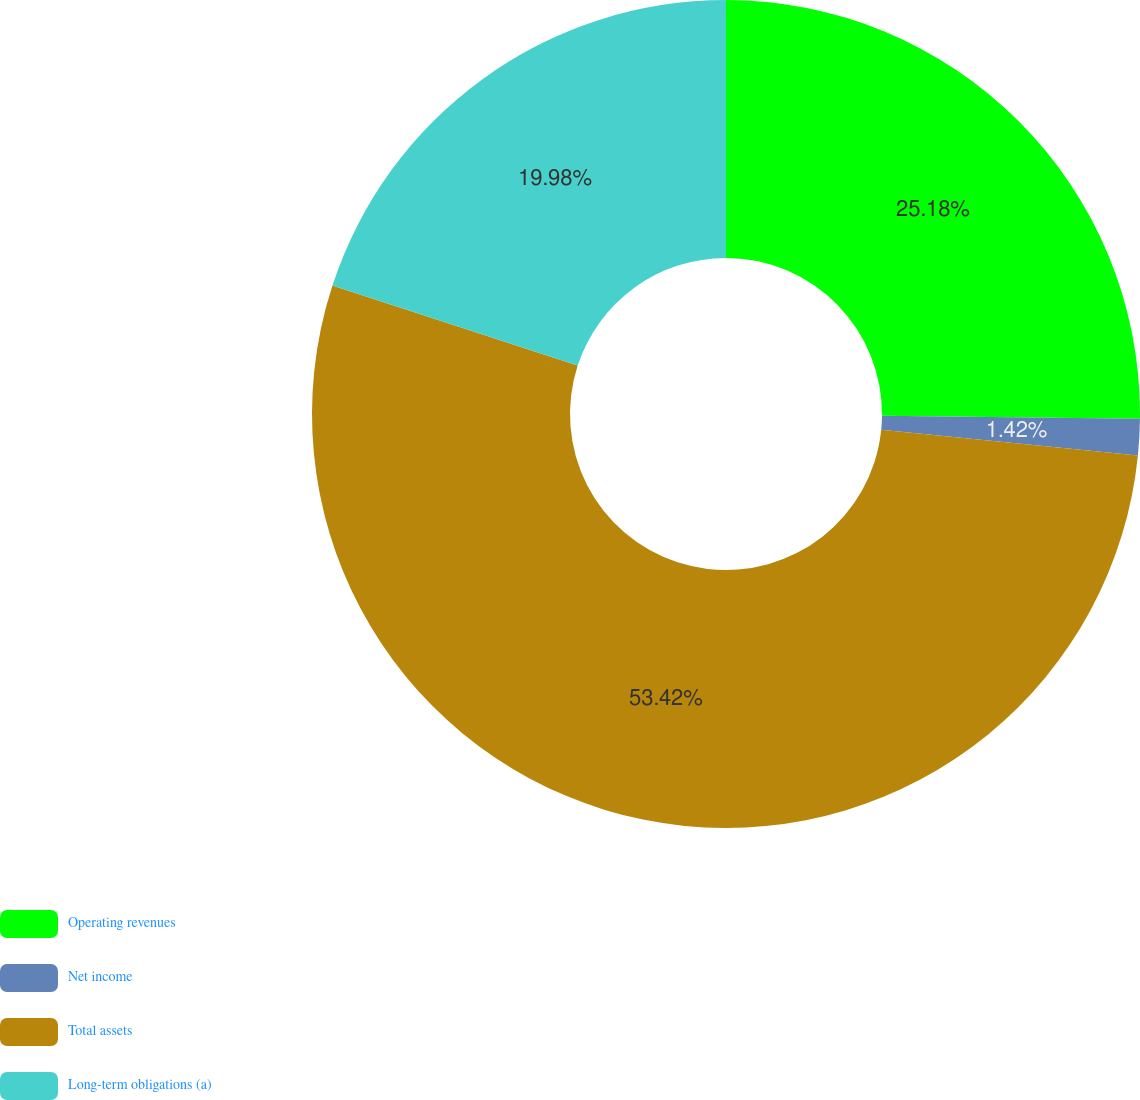<chart> <loc_0><loc_0><loc_500><loc_500><pie_chart><fcel>Operating revenues<fcel>Net income<fcel>Total assets<fcel>Long-term obligations (a)<nl><fcel>25.18%<fcel>1.42%<fcel>53.42%<fcel>19.98%<nl></chart> 